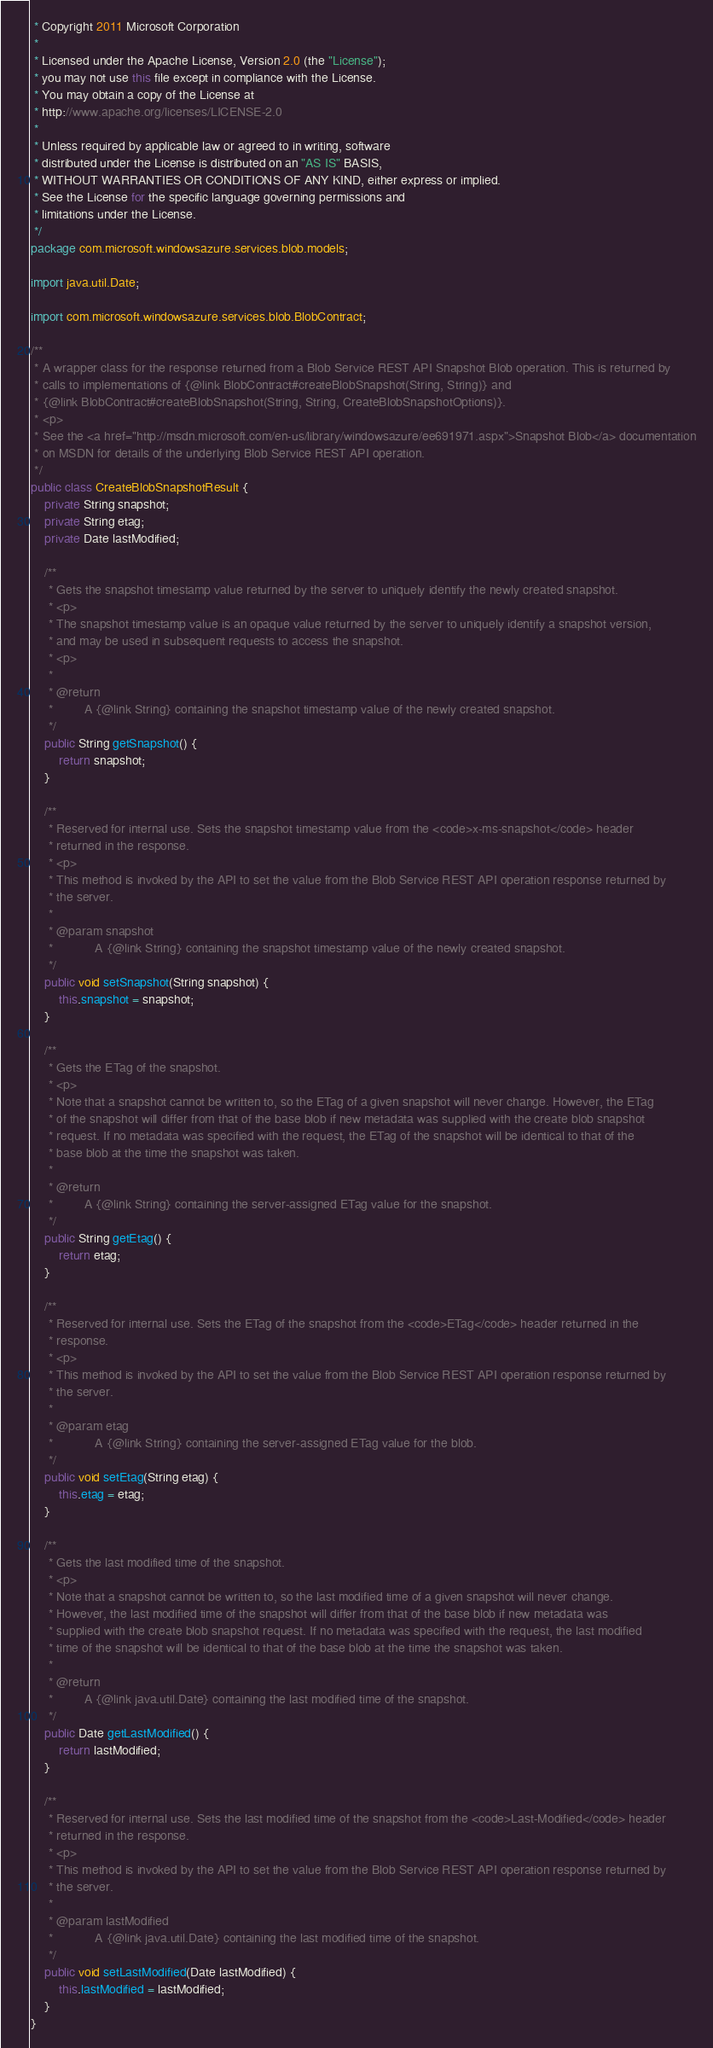Convert code to text. <code><loc_0><loc_0><loc_500><loc_500><_Java_> * Copyright 2011 Microsoft Corporation
 * 
 * Licensed under the Apache License, Version 2.0 (the "License");
 * you may not use this file except in compliance with the License.
 * You may obtain a copy of the License at
 * http://www.apache.org/licenses/LICENSE-2.0
 * 
 * Unless required by applicable law or agreed to in writing, software
 * distributed under the License is distributed on an "AS IS" BASIS,
 * WITHOUT WARRANTIES OR CONDITIONS OF ANY KIND, either express or implied.
 * See the License for the specific language governing permissions and
 * limitations under the License.
 */
package com.microsoft.windowsazure.services.blob.models;

import java.util.Date;

import com.microsoft.windowsazure.services.blob.BlobContract;

/**
 * A wrapper class for the response returned from a Blob Service REST API Snapshot Blob operation. This is returned by
 * calls to implementations of {@link BlobContract#createBlobSnapshot(String, String)} and
 * {@link BlobContract#createBlobSnapshot(String, String, CreateBlobSnapshotOptions)}.
 * <p>
 * See the <a href="http://msdn.microsoft.com/en-us/library/windowsazure/ee691971.aspx">Snapshot Blob</a> documentation
 * on MSDN for details of the underlying Blob Service REST API operation.
 */
public class CreateBlobSnapshotResult {
    private String snapshot;
    private String etag;
    private Date lastModified;

    /**
     * Gets the snapshot timestamp value returned by the server to uniquely identify the newly created snapshot.
     * <p>
     * The snapshot timestamp value is an opaque value returned by the server to uniquely identify a snapshot version,
     * and may be used in subsequent requests to access the snapshot.
     * <p>
     * 
     * @return
     *         A {@link String} containing the snapshot timestamp value of the newly created snapshot.
     */
    public String getSnapshot() {
        return snapshot;
    }

    /**
     * Reserved for internal use. Sets the snapshot timestamp value from the <code>x-ms-snapshot</code> header
     * returned in the response.
     * <p>
     * This method is invoked by the API to set the value from the Blob Service REST API operation response returned by
     * the server.
     * 
     * @param snapshot
     *            A {@link String} containing the snapshot timestamp value of the newly created snapshot.
     */
    public void setSnapshot(String snapshot) {
        this.snapshot = snapshot;
    }

    /**
     * Gets the ETag of the snapshot.
     * <p>
     * Note that a snapshot cannot be written to, so the ETag of a given snapshot will never change. However, the ETag
     * of the snapshot will differ from that of the base blob if new metadata was supplied with the create blob snapshot
     * request. If no metadata was specified with the request, the ETag of the snapshot will be identical to that of the
     * base blob at the time the snapshot was taken.
     * 
     * @return
     *         A {@link String} containing the server-assigned ETag value for the snapshot.
     */
    public String getEtag() {
        return etag;
    }

    /**
     * Reserved for internal use. Sets the ETag of the snapshot from the <code>ETag</code> header returned in the
     * response.
     * <p>
     * This method is invoked by the API to set the value from the Blob Service REST API operation response returned by
     * the server.
     * 
     * @param etag
     *            A {@link String} containing the server-assigned ETag value for the blob.
     */
    public void setEtag(String etag) {
        this.etag = etag;
    }

    /**
     * Gets the last modified time of the snapshot.
     * <p>
     * Note that a snapshot cannot be written to, so the last modified time of a given snapshot will never change.
     * However, the last modified time of the snapshot will differ from that of the base blob if new metadata was
     * supplied with the create blob snapshot request. If no metadata was specified with the request, the last modified
     * time of the snapshot will be identical to that of the base blob at the time the snapshot was taken.
     * 
     * @return
     *         A {@link java.util.Date} containing the last modified time of the snapshot.
     */
    public Date getLastModified() {
        return lastModified;
    }

    /**
     * Reserved for internal use. Sets the last modified time of the snapshot from the <code>Last-Modified</code> header
     * returned in the response.
     * <p>
     * This method is invoked by the API to set the value from the Blob Service REST API operation response returned by
     * the server.
     * 
     * @param lastModified
     *            A {@link java.util.Date} containing the last modified time of the snapshot.
     */
    public void setLastModified(Date lastModified) {
        this.lastModified = lastModified;
    }
}
</code> 